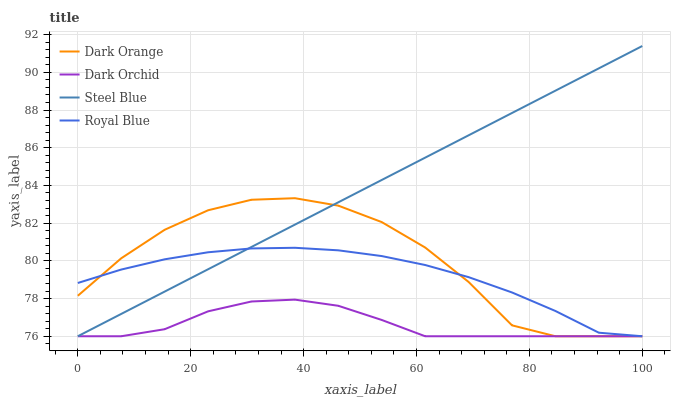Does Dark Orchid have the minimum area under the curve?
Answer yes or no. Yes. Does Steel Blue have the maximum area under the curve?
Answer yes or no. Yes. Does Steel Blue have the minimum area under the curve?
Answer yes or no. No. Does Dark Orchid have the maximum area under the curve?
Answer yes or no. No. Is Steel Blue the smoothest?
Answer yes or no. Yes. Is Dark Orange the roughest?
Answer yes or no. Yes. Is Dark Orchid the smoothest?
Answer yes or no. No. Is Dark Orchid the roughest?
Answer yes or no. No. Does Dark Orange have the lowest value?
Answer yes or no. Yes. Does Steel Blue have the highest value?
Answer yes or no. Yes. Does Dark Orchid have the highest value?
Answer yes or no. No. Does Dark Orchid intersect Dark Orange?
Answer yes or no. Yes. Is Dark Orchid less than Dark Orange?
Answer yes or no. No. Is Dark Orchid greater than Dark Orange?
Answer yes or no. No. 